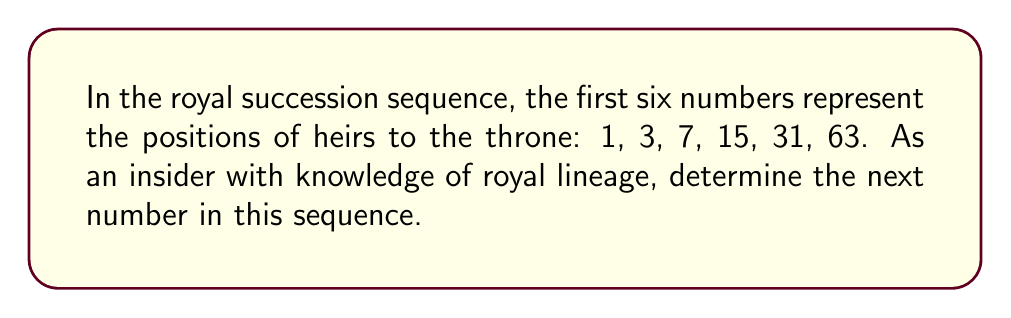Could you help me with this problem? To solve this sequence, we need to analyze the pattern:

1. Let's look at the differences between consecutive terms:
   $3 - 1 = 2$
   $7 - 3 = 4$
   $15 - 7 = 8$
   $31 - 15 = 16$
   $63 - 31 = 32$

2. We can observe that each difference is doubling:
   $2, 4, 8, 16, 32$

3. This suggests that the next difference will be $64$.

4. To find the next term, we add this difference to the last term:
   $63 + 64 = 127$

5. We can verify this pattern mathematically:
   Let $a_n$ be the $n$-th term in the sequence.
   We can express the general term as:
   $$a_n = 2^n - 1$$

6. Let's verify for the given terms:
   $a_1 = 2^1 - 1 = 1$
   $a_2 = 2^2 - 1 = 3$
   $a_3 = 2^3 - 1 = 7$
   $a_4 = 2^4 - 1 = 15$
   $a_5 = 2^5 - 1 = 31$
   $a_6 = 2^6 - 1 = 63$

7. Therefore, the next term (7th term) would be:
   $a_7 = 2^7 - 1 = 128 - 1 = 127$

This sequence represents the maximum number of people in each generation of the royal family who could potentially be in line for the throne, assuming each person has two children.
Answer: 127 